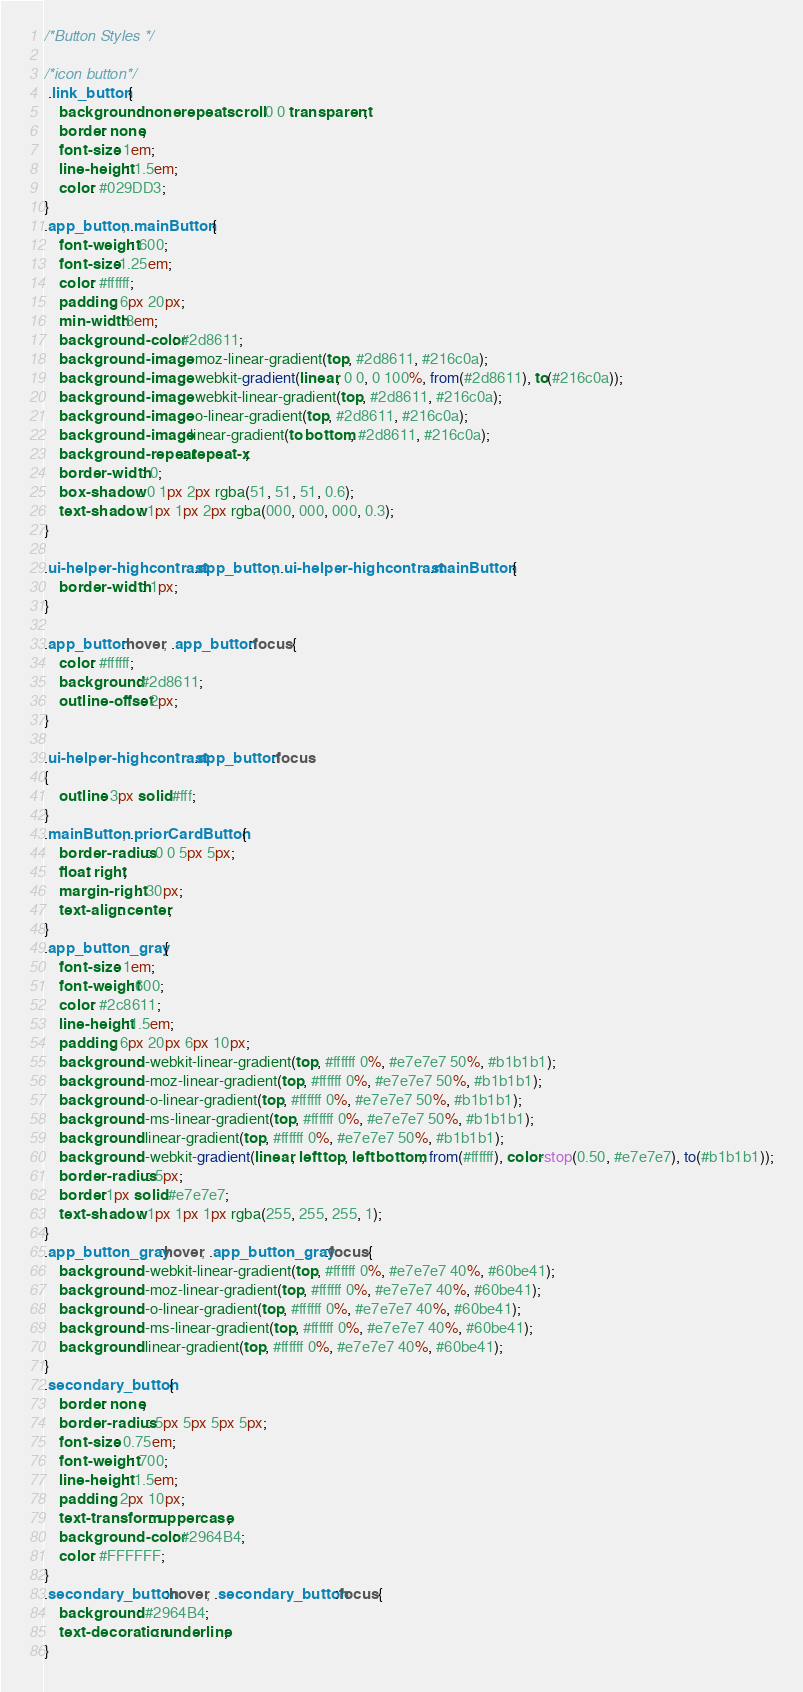<code> <loc_0><loc_0><loc_500><loc_500><_CSS_>/*Button Styles */

/*icon button*/
 .link_button {
	background: none repeat scroll 0 0 transparent;
	border: none;
	font-size: 1em;
	line-height: 1.5em;
	color: #029DD3;
}
.app_button, .mainButton {
	font-weight: 600;
	font-size:1.25em;
	color: #ffffff;
	padding: 6px 20px;
	min-width:8em;
	background-color: #2d8611;
	background-image: -moz-linear-gradient(top, #2d8611, #216c0a);
	background-image: -webkit-gradient(linear, 0 0, 0 100%, from(#2d8611), to(#216c0a));
	background-image: -webkit-linear-gradient(top, #2d8611, #216c0a);
	background-image: -o-linear-gradient(top, #2d8611, #216c0a);
	background-image: linear-gradient(to bottom, #2d8611, #216c0a);
	background-repeat: repeat-x;
	border-width: 0;
	box-shadow: 0 1px 2px rgba(51, 51, 51, 0.6);
	text-shadow: 1px 1px 2px rgba(000, 000, 000, 0.3);
}

.ui-helper-highcontrast .app_button, .ui-helper-highcontrast .mainButton {
	border-width: 1px;
}

.app_button:hover, .app_button:focus {
	color: #ffffff;
	background:#2d8611;
	outline-offset: 2px;
}

.ui-helper-highcontrast .app_button:focus
{
	outline: 3px solid #fff;
}
.mainButton, .priorCardButton {
	border-radius: 0 0 5px 5px;
	float: right;
	margin-right: 30px;
	text-align: center;
}
.app_button_gray {
	font-size: 1em;
	font-weight:600;
	color: #2c8611;
	line-height:1.5em;
	padding: 6px 20px 6px 10px;
	background: -webkit-linear-gradient(top, #ffffff 0%, #e7e7e7 50%, #b1b1b1);
	background: -moz-linear-gradient(top, #ffffff 0%, #e7e7e7 50%, #b1b1b1);
	background: -o-linear-gradient(top, #ffffff 0%, #e7e7e7 50%, #b1b1b1);
	background: -ms-linear-gradient(top, #ffffff 0%, #e7e7e7 50%, #b1b1b1);
	background: linear-gradient(top, #ffffff 0%, #e7e7e7 50%, #b1b1b1);
	background: -webkit-gradient(linear, left top, left bottom, from(#ffffff), color-stop(0.50, #e7e7e7), to(#b1b1b1));
	border-radius: 5px;
	border:1px solid #e7e7e7;
	text-shadow: 1px 1px 1px rgba(255, 255, 255, 1);
}
.app_button_gray:hover, .app_button_gray:focus {
	background: -webkit-linear-gradient(top, #ffffff 0%, #e7e7e7 40%, #60be41);
	background: -moz-linear-gradient(top, #ffffff 0%, #e7e7e7 40%, #60be41);
	background: -o-linear-gradient(top, #ffffff 0%, #e7e7e7 40%, #60be41);
	background: -ms-linear-gradient(top, #ffffff 0%, #e7e7e7 40%, #60be41);
	background: linear-gradient(top, #ffffff 0%, #e7e7e7 40%, #60be41);
}
.secondary_button {
	border: none;
	border-radius: 5px 5px 5px 5px;
	font-size: 0.75em;
	font-weight: 700;
	line-height: 1.5em;
	padding: 2px 10px;
	text-transform: uppercase;
	background-color: #2964B4;
	color: #FFFFFF;
}
.secondary_button:hover, .secondary_button:focus {
	background: #2964B4;
	text-decoration: underline;
}
</code> 